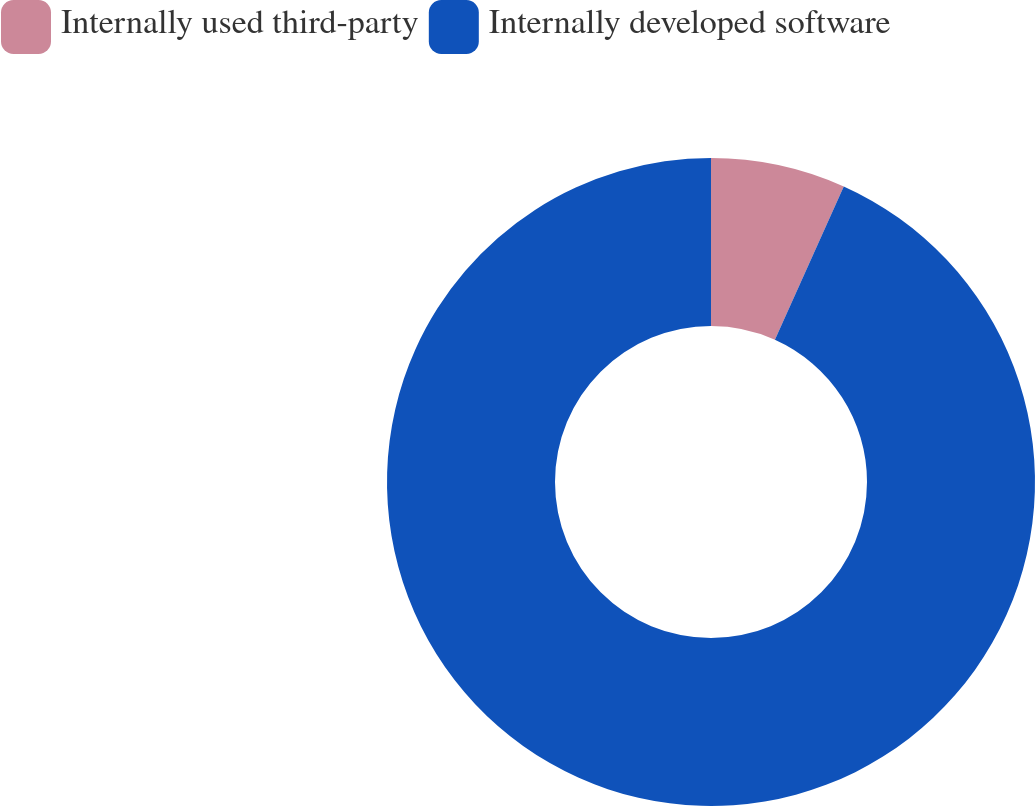Convert chart to OTSL. <chart><loc_0><loc_0><loc_500><loc_500><pie_chart><fcel>Internally used third-party<fcel>Internally developed software<nl><fcel>6.72%<fcel>93.28%<nl></chart> 